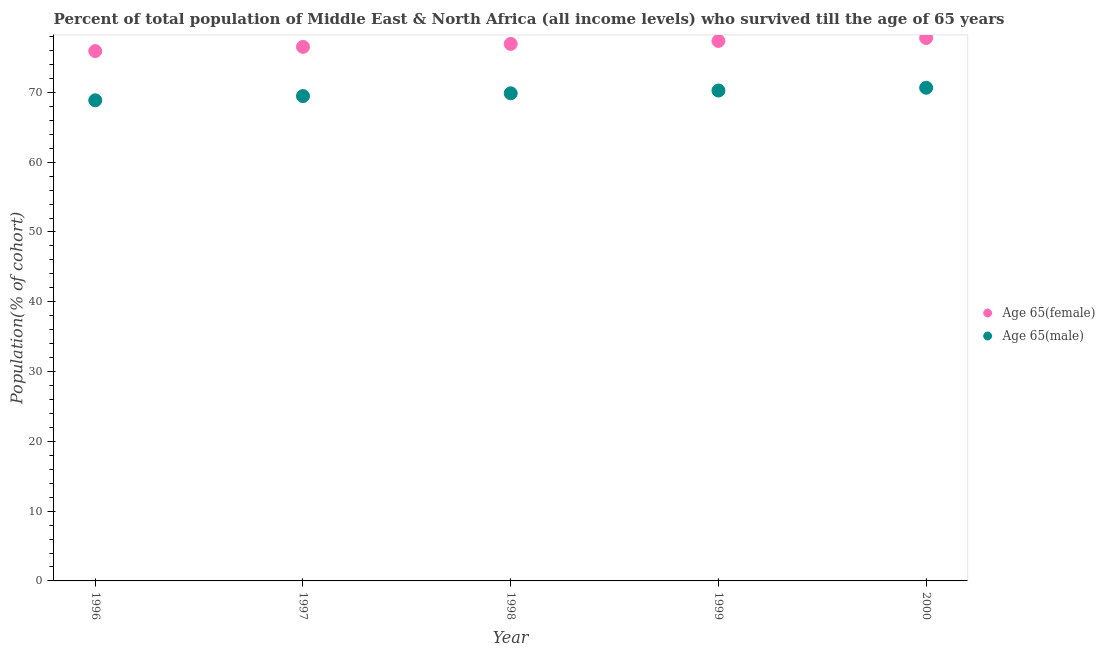What is the percentage of male population who survived till age of 65 in 1996?
Keep it short and to the point. 68.87. Across all years, what is the maximum percentage of female population who survived till age of 65?
Ensure brevity in your answer.  77.8. Across all years, what is the minimum percentage of male population who survived till age of 65?
Your answer should be compact. 68.87. In which year was the percentage of female population who survived till age of 65 maximum?
Your response must be concise. 2000. What is the total percentage of female population who survived till age of 65 in the graph?
Your answer should be very brief. 384.57. What is the difference between the percentage of male population who survived till age of 65 in 1998 and that in 2000?
Provide a short and direct response. -0.79. What is the difference between the percentage of male population who survived till age of 65 in 1997 and the percentage of female population who survived till age of 65 in 2000?
Your response must be concise. -8.32. What is the average percentage of male population who survived till age of 65 per year?
Provide a succinct answer. 69.83. In the year 2000, what is the difference between the percentage of female population who survived till age of 65 and percentage of male population who survived till age of 65?
Offer a very short reply. 7.13. What is the ratio of the percentage of male population who survived till age of 65 in 1999 to that in 2000?
Your answer should be very brief. 0.99. Is the percentage of female population who survived till age of 65 in 1997 less than that in 2000?
Your response must be concise. Yes. What is the difference between the highest and the second highest percentage of male population who survived till age of 65?
Offer a very short reply. 0.4. What is the difference between the highest and the lowest percentage of female population who survived till age of 65?
Offer a terse response. 1.87. Does the percentage of female population who survived till age of 65 monotonically increase over the years?
Keep it short and to the point. Yes. Does the graph contain any zero values?
Keep it short and to the point. No. Does the graph contain grids?
Give a very brief answer. No. How are the legend labels stacked?
Make the answer very short. Vertical. What is the title of the graph?
Make the answer very short. Percent of total population of Middle East & North Africa (all income levels) who survived till the age of 65 years. What is the label or title of the X-axis?
Provide a succinct answer. Year. What is the label or title of the Y-axis?
Offer a very short reply. Population(% of cohort). What is the Population(% of cohort) in Age 65(female) in 1996?
Your response must be concise. 75.92. What is the Population(% of cohort) of Age 65(male) in 1996?
Provide a succinct answer. 68.87. What is the Population(% of cohort) in Age 65(female) in 1997?
Provide a succinct answer. 76.53. What is the Population(% of cohort) in Age 65(male) in 1997?
Provide a short and direct response. 69.47. What is the Population(% of cohort) in Age 65(female) in 1998?
Offer a terse response. 76.95. What is the Population(% of cohort) of Age 65(male) in 1998?
Offer a terse response. 69.87. What is the Population(% of cohort) in Age 65(female) in 1999?
Your answer should be very brief. 77.37. What is the Population(% of cohort) of Age 65(male) in 1999?
Offer a very short reply. 70.27. What is the Population(% of cohort) of Age 65(female) in 2000?
Offer a very short reply. 77.8. What is the Population(% of cohort) in Age 65(male) in 2000?
Provide a succinct answer. 70.67. Across all years, what is the maximum Population(% of cohort) of Age 65(female)?
Give a very brief answer. 77.8. Across all years, what is the maximum Population(% of cohort) of Age 65(male)?
Your answer should be very brief. 70.67. Across all years, what is the minimum Population(% of cohort) of Age 65(female)?
Ensure brevity in your answer.  75.92. Across all years, what is the minimum Population(% of cohort) in Age 65(male)?
Offer a terse response. 68.87. What is the total Population(% of cohort) in Age 65(female) in the graph?
Give a very brief answer. 384.57. What is the total Population(% of cohort) in Age 65(male) in the graph?
Ensure brevity in your answer.  349.15. What is the difference between the Population(% of cohort) in Age 65(female) in 1996 and that in 1997?
Your answer should be very brief. -0.6. What is the difference between the Population(% of cohort) of Age 65(male) in 1996 and that in 1997?
Provide a succinct answer. -0.61. What is the difference between the Population(% of cohort) in Age 65(female) in 1996 and that in 1998?
Offer a very short reply. -1.03. What is the difference between the Population(% of cohort) of Age 65(male) in 1996 and that in 1998?
Your answer should be very brief. -1. What is the difference between the Population(% of cohort) in Age 65(female) in 1996 and that in 1999?
Offer a very short reply. -1.45. What is the difference between the Population(% of cohort) in Age 65(male) in 1996 and that in 1999?
Make the answer very short. -1.4. What is the difference between the Population(% of cohort) of Age 65(female) in 1996 and that in 2000?
Ensure brevity in your answer.  -1.87. What is the difference between the Population(% of cohort) of Age 65(male) in 1996 and that in 2000?
Ensure brevity in your answer.  -1.8. What is the difference between the Population(% of cohort) in Age 65(female) in 1997 and that in 1998?
Provide a short and direct response. -0.42. What is the difference between the Population(% of cohort) in Age 65(male) in 1997 and that in 1998?
Provide a short and direct response. -0.4. What is the difference between the Population(% of cohort) in Age 65(female) in 1997 and that in 1999?
Give a very brief answer. -0.85. What is the difference between the Population(% of cohort) of Age 65(male) in 1997 and that in 1999?
Your response must be concise. -0.8. What is the difference between the Population(% of cohort) of Age 65(female) in 1997 and that in 2000?
Your response must be concise. -1.27. What is the difference between the Population(% of cohort) in Age 65(male) in 1997 and that in 2000?
Your answer should be compact. -1.19. What is the difference between the Population(% of cohort) in Age 65(female) in 1998 and that in 1999?
Ensure brevity in your answer.  -0.42. What is the difference between the Population(% of cohort) in Age 65(male) in 1998 and that in 1999?
Give a very brief answer. -0.4. What is the difference between the Population(% of cohort) of Age 65(female) in 1998 and that in 2000?
Give a very brief answer. -0.85. What is the difference between the Population(% of cohort) of Age 65(male) in 1998 and that in 2000?
Your answer should be compact. -0.79. What is the difference between the Population(% of cohort) of Age 65(female) in 1999 and that in 2000?
Ensure brevity in your answer.  -0.42. What is the difference between the Population(% of cohort) in Age 65(male) in 1999 and that in 2000?
Ensure brevity in your answer.  -0.4. What is the difference between the Population(% of cohort) of Age 65(female) in 1996 and the Population(% of cohort) of Age 65(male) in 1997?
Ensure brevity in your answer.  6.45. What is the difference between the Population(% of cohort) of Age 65(female) in 1996 and the Population(% of cohort) of Age 65(male) in 1998?
Your answer should be compact. 6.05. What is the difference between the Population(% of cohort) in Age 65(female) in 1996 and the Population(% of cohort) in Age 65(male) in 1999?
Provide a succinct answer. 5.65. What is the difference between the Population(% of cohort) in Age 65(female) in 1996 and the Population(% of cohort) in Age 65(male) in 2000?
Your response must be concise. 5.26. What is the difference between the Population(% of cohort) in Age 65(female) in 1997 and the Population(% of cohort) in Age 65(male) in 1998?
Provide a succinct answer. 6.65. What is the difference between the Population(% of cohort) of Age 65(female) in 1997 and the Population(% of cohort) of Age 65(male) in 1999?
Offer a very short reply. 6.26. What is the difference between the Population(% of cohort) of Age 65(female) in 1997 and the Population(% of cohort) of Age 65(male) in 2000?
Your response must be concise. 5.86. What is the difference between the Population(% of cohort) of Age 65(female) in 1998 and the Population(% of cohort) of Age 65(male) in 1999?
Provide a succinct answer. 6.68. What is the difference between the Population(% of cohort) of Age 65(female) in 1998 and the Population(% of cohort) of Age 65(male) in 2000?
Your response must be concise. 6.28. What is the difference between the Population(% of cohort) of Age 65(female) in 1999 and the Population(% of cohort) of Age 65(male) in 2000?
Your answer should be compact. 6.71. What is the average Population(% of cohort) in Age 65(female) per year?
Provide a succinct answer. 76.91. What is the average Population(% of cohort) in Age 65(male) per year?
Provide a succinct answer. 69.83. In the year 1996, what is the difference between the Population(% of cohort) of Age 65(female) and Population(% of cohort) of Age 65(male)?
Ensure brevity in your answer.  7.05. In the year 1997, what is the difference between the Population(% of cohort) of Age 65(female) and Population(% of cohort) of Age 65(male)?
Offer a very short reply. 7.05. In the year 1998, what is the difference between the Population(% of cohort) in Age 65(female) and Population(% of cohort) in Age 65(male)?
Your answer should be very brief. 7.08. In the year 1999, what is the difference between the Population(% of cohort) in Age 65(female) and Population(% of cohort) in Age 65(male)?
Make the answer very short. 7.1. In the year 2000, what is the difference between the Population(% of cohort) of Age 65(female) and Population(% of cohort) of Age 65(male)?
Provide a succinct answer. 7.13. What is the ratio of the Population(% of cohort) in Age 65(female) in 1996 to that in 1997?
Make the answer very short. 0.99. What is the ratio of the Population(% of cohort) of Age 65(male) in 1996 to that in 1997?
Your answer should be very brief. 0.99. What is the ratio of the Population(% of cohort) in Age 65(female) in 1996 to that in 1998?
Make the answer very short. 0.99. What is the ratio of the Population(% of cohort) in Age 65(male) in 1996 to that in 1998?
Provide a short and direct response. 0.99. What is the ratio of the Population(% of cohort) in Age 65(female) in 1996 to that in 1999?
Offer a very short reply. 0.98. What is the ratio of the Population(% of cohort) of Age 65(male) in 1996 to that in 1999?
Make the answer very short. 0.98. What is the ratio of the Population(% of cohort) in Age 65(female) in 1996 to that in 2000?
Your answer should be very brief. 0.98. What is the ratio of the Population(% of cohort) of Age 65(male) in 1996 to that in 2000?
Your answer should be compact. 0.97. What is the ratio of the Population(% of cohort) of Age 65(female) in 1997 to that in 1999?
Give a very brief answer. 0.99. What is the ratio of the Population(% of cohort) in Age 65(male) in 1997 to that in 1999?
Provide a succinct answer. 0.99. What is the ratio of the Population(% of cohort) of Age 65(female) in 1997 to that in 2000?
Your answer should be very brief. 0.98. What is the ratio of the Population(% of cohort) in Age 65(male) in 1997 to that in 2000?
Offer a very short reply. 0.98. What is the ratio of the Population(% of cohort) of Age 65(female) in 1998 to that in 1999?
Ensure brevity in your answer.  0.99. What is the ratio of the Population(% of cohort) of Age 65(male) in 1998 to that in 1999?
Keep it short and to the point. 0.99. What is the ratio of the Population(% of cohort) in Age 65(male) in 1998 to that in 2000?
Your response must be concise. 0.99. What is the ratio of the Population(% of cohort) in Age 65(female) in 1999 to that in 2000?
Give a very brief answer. 0.99. What is the difference between the highest and the second highest Population(% of cohort) in Age 65(female)?
Give a very brief answer. 0.42. What is the difference between the highest and the second highest Population(% of cohort) in Age 65(male)?
Make the answer very short. 0.4. What is the difference between the highest and the lowest Population(% of cohort) in Age 65(female)?
Give a very brief answer. 1.87. What is the difference between the highest and the lowest Population(% of cohort) of Age 65(male)?
Ensure brevity in your answer.  1.8. 